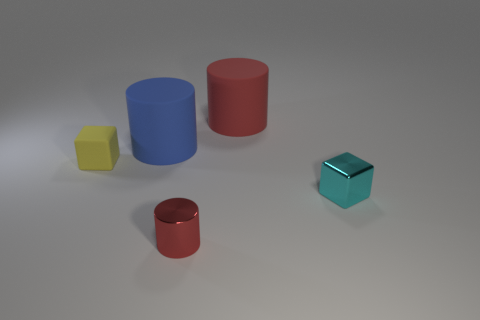Add 2 small objects. How many objects exist? 7 Subtract all cylinders. How many objects are left? 2 Subtract 0 purple balls. How many objects are left? 5 Subtract all blue rubber things. Subtract all blue metallic balls. How many objects are left? 4 Add 1 small cyan metallic cubes. How many small cyan metallic cubes are left? 2 Add 3 small purple objects. How many small purple objects exist? 3 